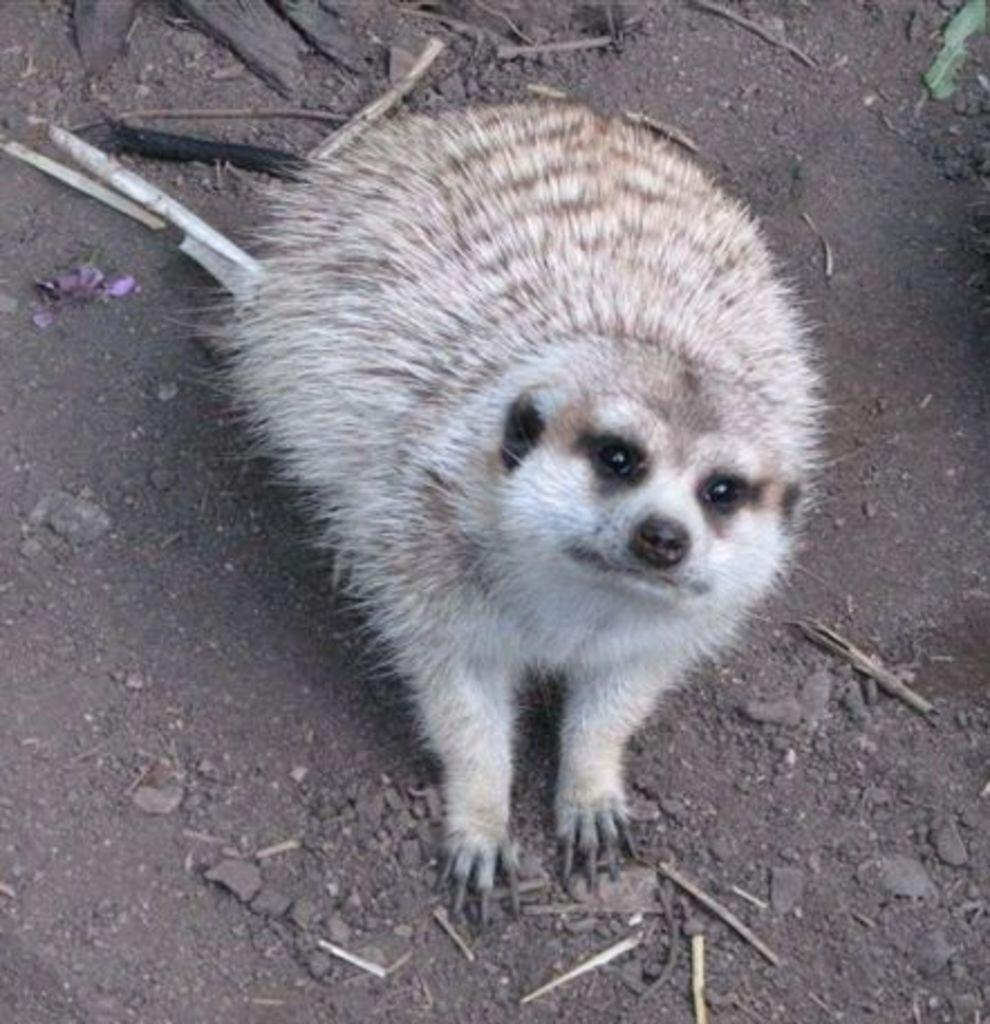Can you describe this image briefly? This picture is clicked outside. In the center there is a white color animal sitting on the ground. In the background there are some items placed on the ground. 